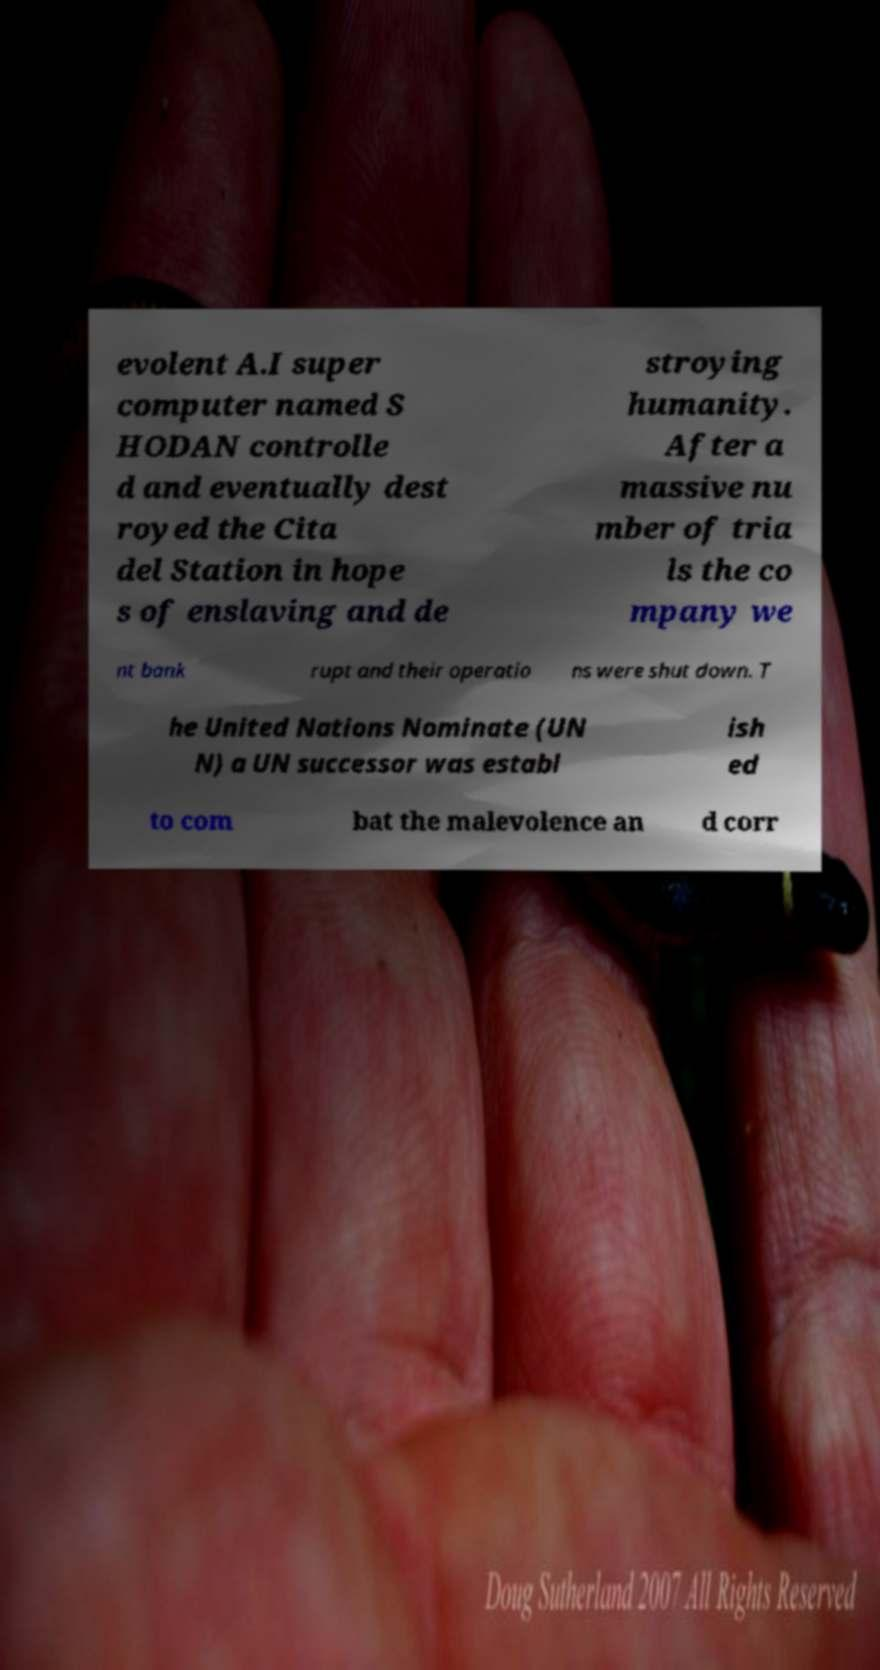Can you accurately transcribe the text from the provided image for me? evolent A.I super computer named S HODAN controlle d and eventually dest royed the Cita del Station in hope s of enslaving and de stroying humanity. After a massive nu mber of tria ls the co mpany we nt bank rupt and their operatio ns were shut down. T he United Nations Nominate (UN N) a UN successor was establ ish ed to com bat the malevolence an d corr 